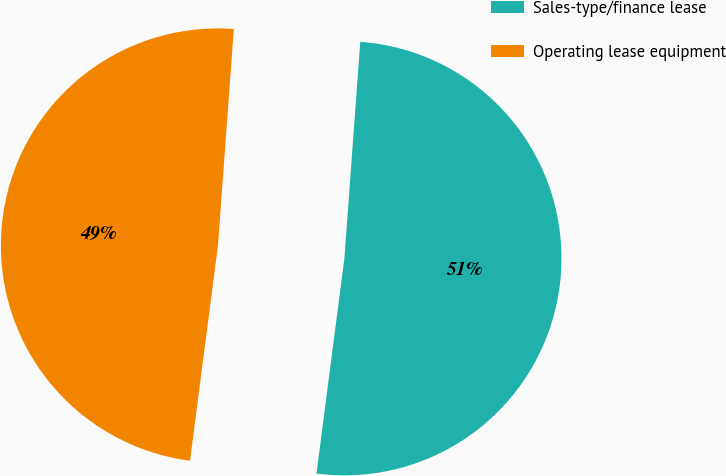Convert chart to OTSL. <chart><loc_0><loc_0><loc_500><loc_500><pie_chart><fcel>Sales-type/finance lease<fcel>Operating lease equipment<nl><fcel>50.89%<fcel>49.11%<nl></chart> 